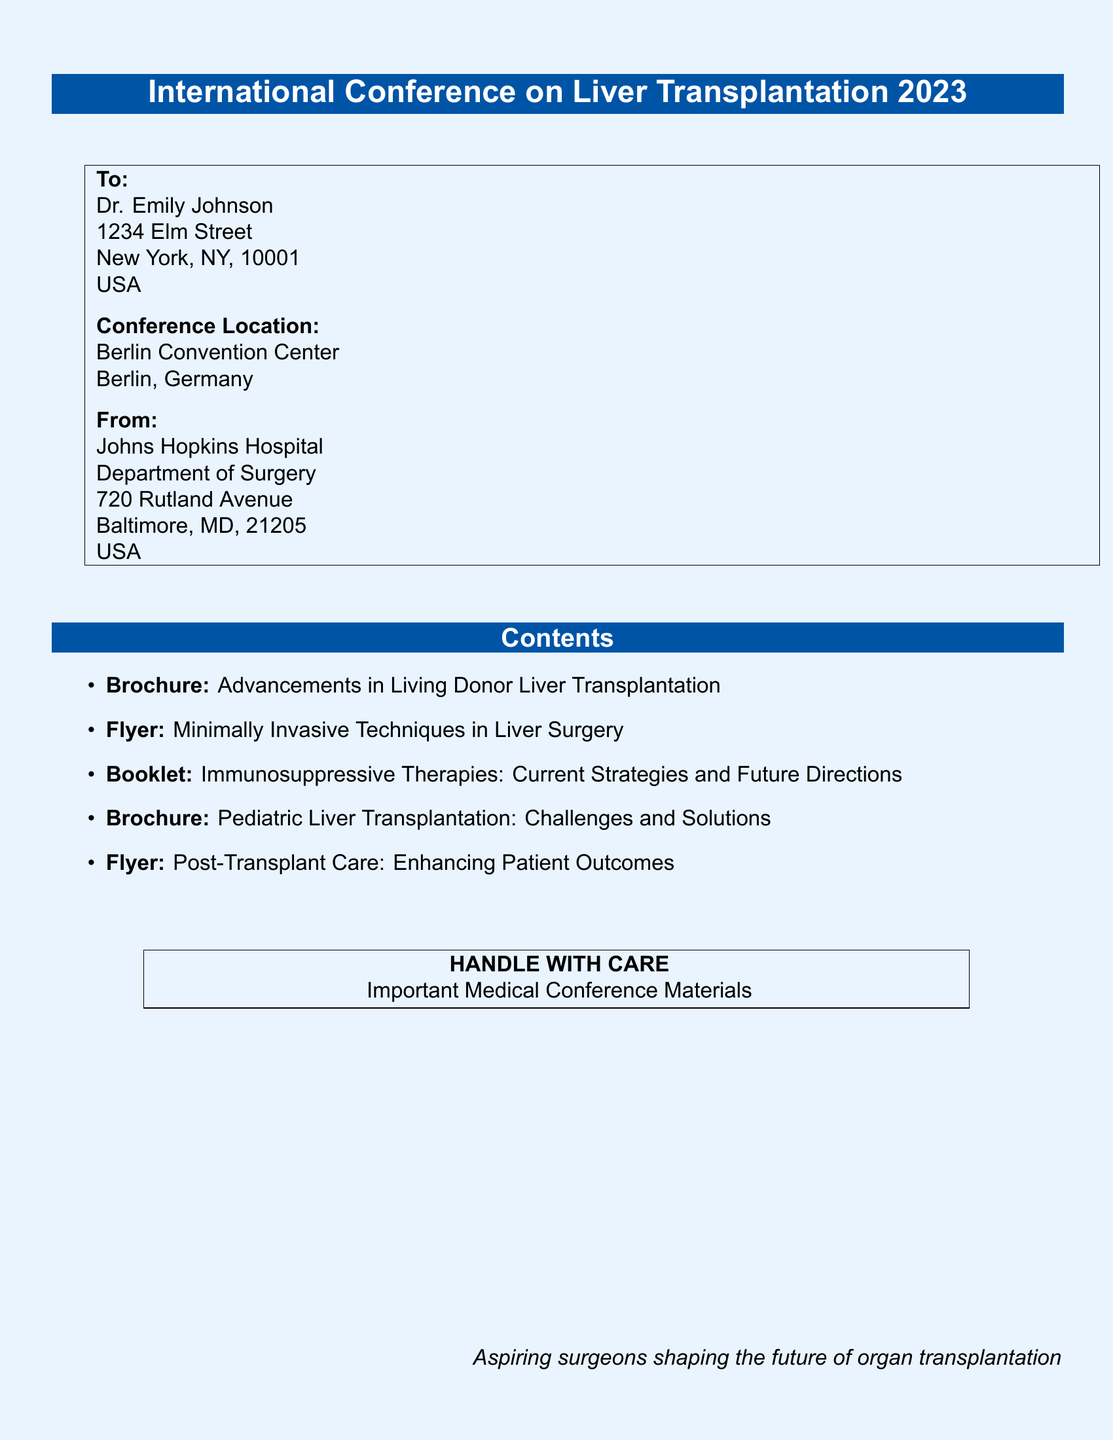What is the name of the conference? The name of the conference is indicated at the top of the document.
Answer: International Conference on Liver Transplantation 2023 Who is the recipient of the parcel? The recipient's name is provided in the "To" section of the document.
Answer: Dr. Emily Johnson What is the conference location? The location of the conference is specified in the document.
Answer: Berlin Convention Center, Berlin, Germany What is the name of the sender institution? The sender's institution is listed in the "From" section.
Answer: Johns Hopkins Hospital How many brochures are included in the contents? The list of contents specifies the number of brochures.
Answer: 2 What is one of the topics covered in the flyers? The document includes specific topics listed under flyers.
Answer: Minimally Invasive Techniques in Liver Surgery What should be done with the parcel according to the document? The document contains a note regarding the handling of the parcel.
Answer: HANDLE WITH CARE What type of materials are being shipped? The document specifies the nature of the materials being shipped.
Answer: Important Medical Conference Materials 